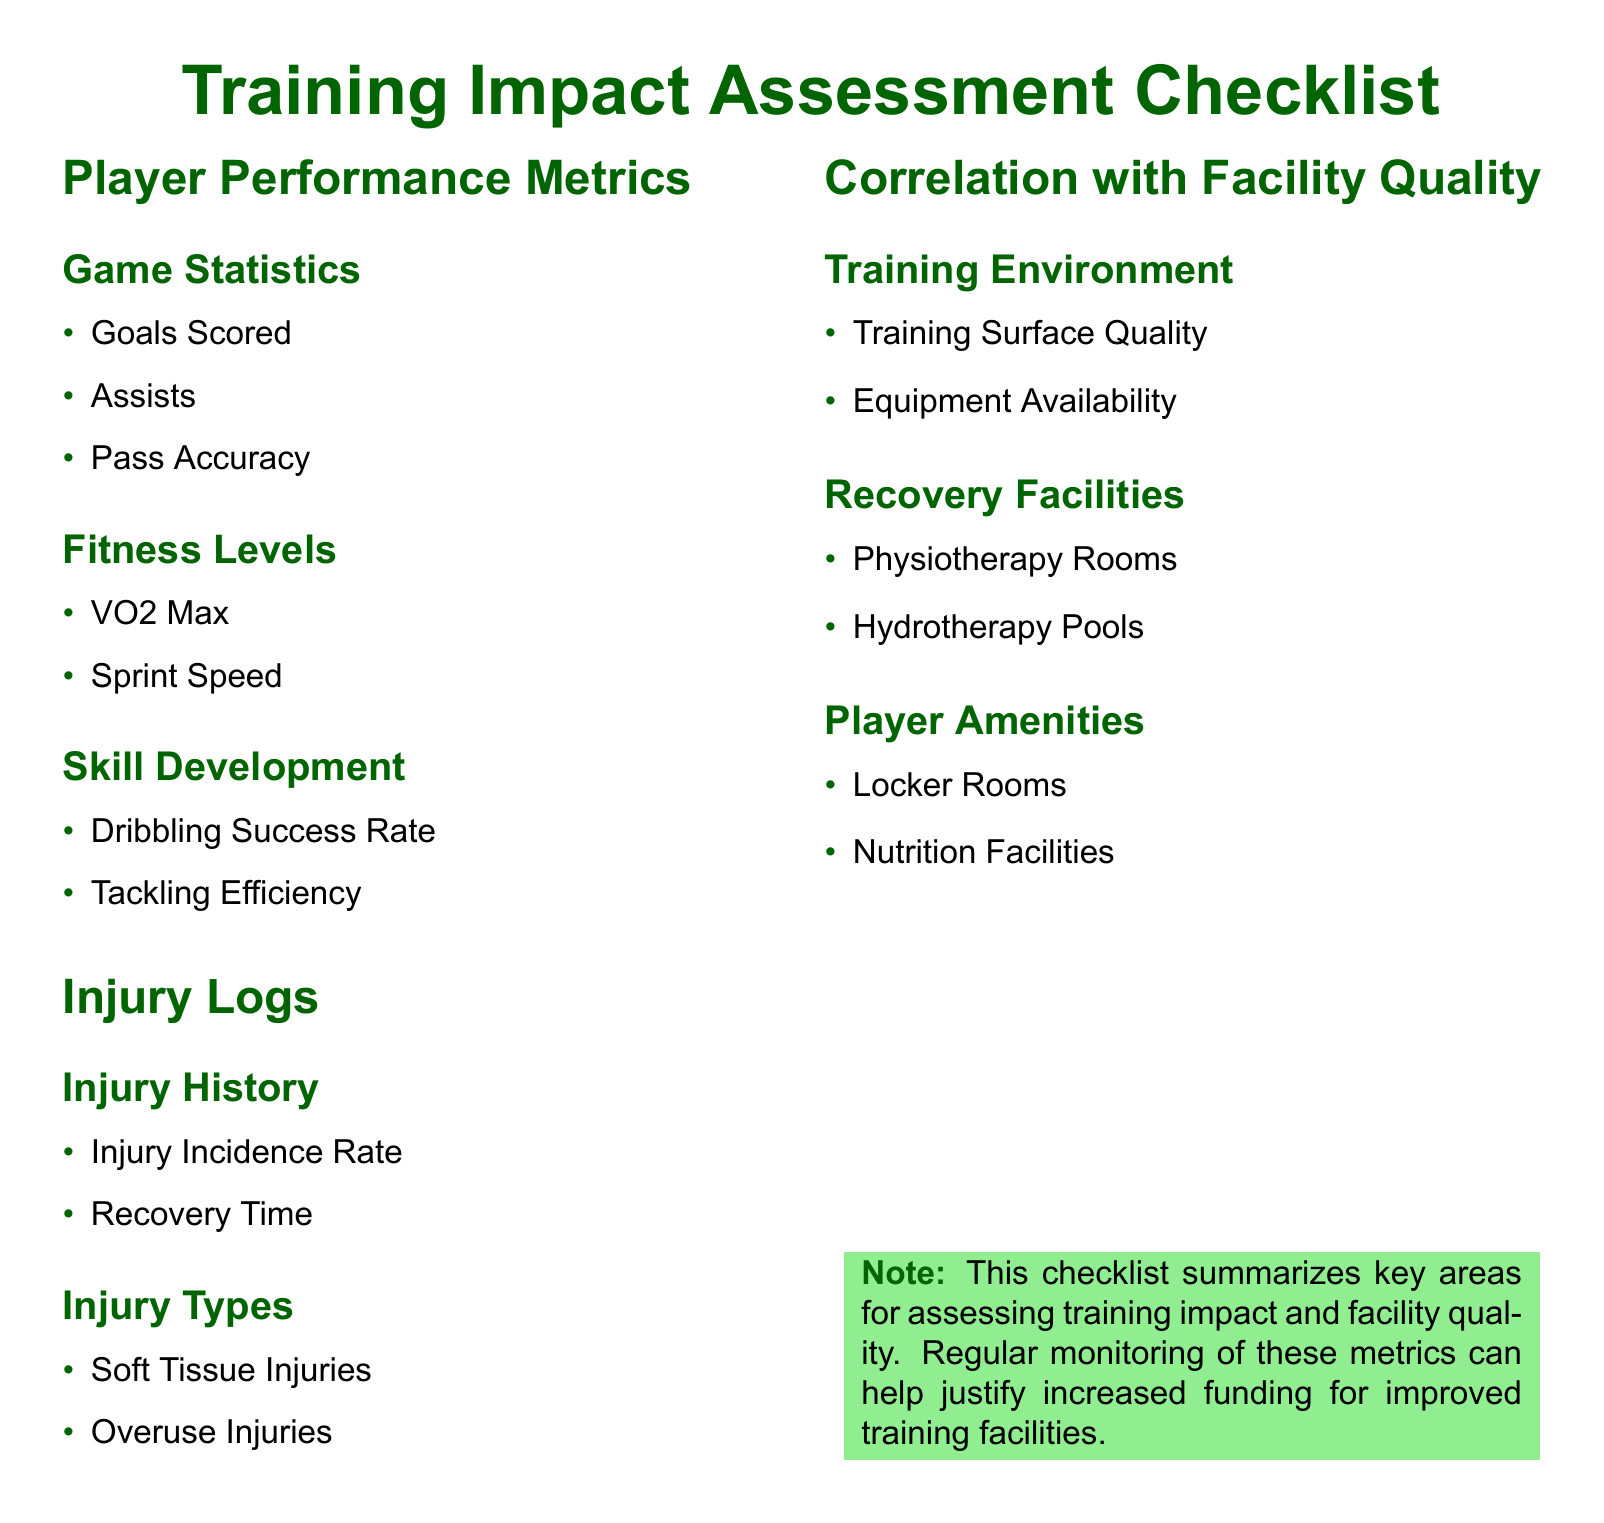What are the game statistics listed? The game statistics include the metrics that measure players' contributions in games, such as goals scored, assists, and pass accuracy.
Answer: Goals Scored, Assists, Pass Accuracy What are the two types of injuries mentioned? The document lists soft tissue injuries and overuse injuries as types of injuries that may be monitored.
Answer: Soft Tissue Injuries, Overuse Injuries What fitness level metric is included for players? The fitness levels include important measures that reflect players' physical capabilities, such as VO2 Max and sprint speed.
Answer: VO2 Max, Sprint Speed How many player amenities are listed? The checklist includes three specific player amenities that support comfort and performance, which are locker rooms and nutrition facilities.
Answer: 2 What is an example of a training environment quality metric? The quality of the training environment can be assessed through the condition of the training surface and the availability of equipment.
Answer: Training Surface Quality Which facility type is specifically mentioned for recovery? The checklist includes various recovery facilities that support player rehabilitation and recovery, specifically physiotherapy rooms and hydrotherapy pools.
Answer: Physiotherapy Rooms, Hydrotherapy Pools What is the purpose of the checklist? The checklist summarizes areas crucial for evaluating training impact and facility quality, aimed at justifying funding needs.
Answer: Justify increased funding How are injury metrics categorized? Injury metrics are organized into two categories based on their characteristics: injury history and types of injuries.
Answer: Injury History, Injury Types 